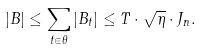Convert formula to latex. <formula><loc_0><loc_0><loc_500><loc_500>| B | \leq \sum _ { t \in \theta } | B _ { t } | \leq T \cdot \sqrt { \eta } \cdot J _ { n } .</formula> 